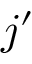Convert formula to latex. <formula><loc_0><loc_0><loc_500><loc_500>j ^ { \prime }</formula> 